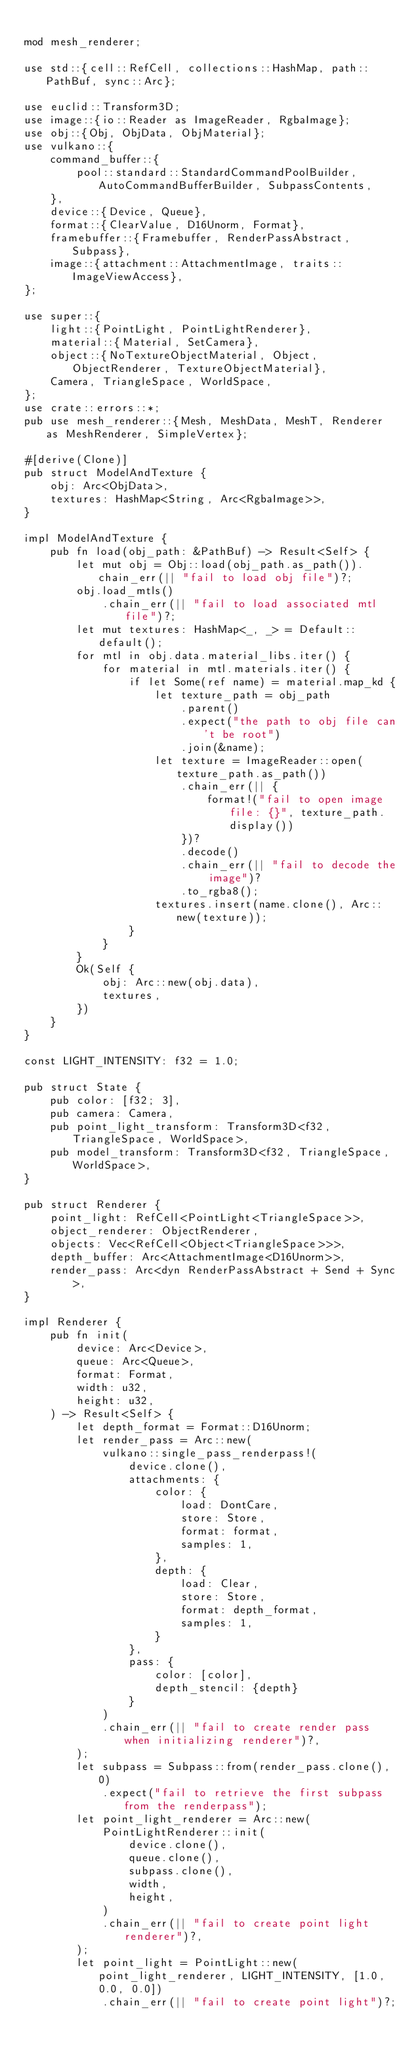<code> <loc_0><loc_0><loc_500><loc_500><_Rust_>
mod mesh_renderer;

use std::{cell::RefCell, collections::HashMap, path::PathBuf, sync::Arc};

use euclid::Transform3D;
use image::{io::Reader as ImageReader, RgbaImage};
use obj::{Obj, ObjData, ObjMaterial};
use vulkano::{
    command_buffer::{
        pool::standard::StandardCommandPoolBuilder, AutoCommandBufferBuilder, SubpassContents,
    },
    device::{Device, Queue},
    format::{ClearValue, D16Unorm, Format},
    framebuffer::{Framebuffer, RenderPassAbstract, Subpass},
    image::{attachment::AttachmentImage, traits::ImageViewAccess},
};

use super::{
    light::{PointLight, PointLightRenderer},
    material::{Material, SetCamera},
    object::{NoTextureObjectMaterial, Object, ObjectRenderer, TextureObjectMaterial},
    Camera, TriangleSpace, WorldSpace,
};
use crate::errors::*;
pub use mesh_renderer::{Mesh, MeshData, MeshT, Renderer as MeshRenderer, SimpleVertex};

#[derive(Clone)]
pub struct ModelAndTexture {
    obj: Arc<ObjData>,
    textures: HashMap<String, Arc<RgbaImage>>,
}

impl ModelAndTexture {
    pub fn load(obj_path: &PathBuf) -> Result<Self> {
        let mut obj = Obj::load(obj_path.as_path()).chain_err(|| "fail to load obj file")?;
        obj.load_mtls()
            .chain_err(|| "fail to load associated mtl file")?;
        let mut textures: HashMap<_, _> = Default::default();
        for mtl in obj.data.material_libs.iter() {
            for material in mtl.materials.iter() {
                if let Some(ref name) = material.map_kd {
                    let texture_path = obj_path
                        .parent()
                        .expect("the path to obj file can't be root")
                        .join(&name);
                    let texture = ImageReader::open(texture_path.as_path())
                        .chain_err(|| {
                            format!("fail to open image file: {}", texture_path.display())
                        })?
                        .decode()
                        .chain_err(|| "fail to decode the image")?
                        .to_rgba8();
                    textures.insert(name.clone(), Arc::new(texture));
                }
            }
        }
        Ok(Self {
            obj: Arc::new(obj.data),
            textures,
        })
    }
}

const LIGHT_INTENSITY: f32 = 1.0;

pub struct State {
    pub color: [f32; 3],
    pub camera: Camera,
    pub point_light_transform: Transform3D<f32, TriangleSpace, WorldSpace>,
    pub model_transform: Transform3D<f32, TriangleSpace, WorldSpace>,
}

pub struct Renderer {
    point_light: RefCell<PointLight<TriangleSpace>>,
    object_renderer: ObjectRenderer,
    objects: Vec<RefCell<Object<TriangleSpace>>>,
    depth_buffer: Arc<AttachmentImage<D16Unorm>>,
    render_pass: Arc<dyn RenderPassAbstract + Send + Sync>,
}

impl Renderer {
    pub fn init(
        device: Arc<Device>,
        queue: Arc<Queue>,
        format: Format,
        width: u32,
        height: u32,
    ) -> Result<Self> {
        let depth_format = Format::D16Unorm;
        let render_pass = Arc::new(
            vulkano::single_pass_renderpass!(
                device.clone(),
                attachments: {
                    color: {
                        load: DontCare,
                        store: Store,
                        format: format,
                        samples: 1,
                    },
                    depth: {
                        load: Clear,
                        store: Store,
                        format: depth_format,
                        samples: 1,
                    }
                },
                pass: {
                    color: [color],
                    depth_stencil: {depth}
                }
            )
            .chain_err(|| "fail to create render pass when initializing renderer")?,
        );
        let subpass = Subpass::from(render_pass.clone(), 0)
            .expect("fail to retrieve the first subpass from the renderpass");
        let point_light_renderer = Arc::new(
            PointLightRenderer::init(
                device.clone(),
                queue.clone(),
                subpass.clone(),
                width,
                height,
            )
            .chain_err(|| "fail to create point light renderer")?,
        );
        let point_light = PointLight::new(point_light_renderer, LIGHT_INTENSITY, [1.0, 0.0, 0.0])
            .chain_err(|| "fail to create point light")?;</code> 